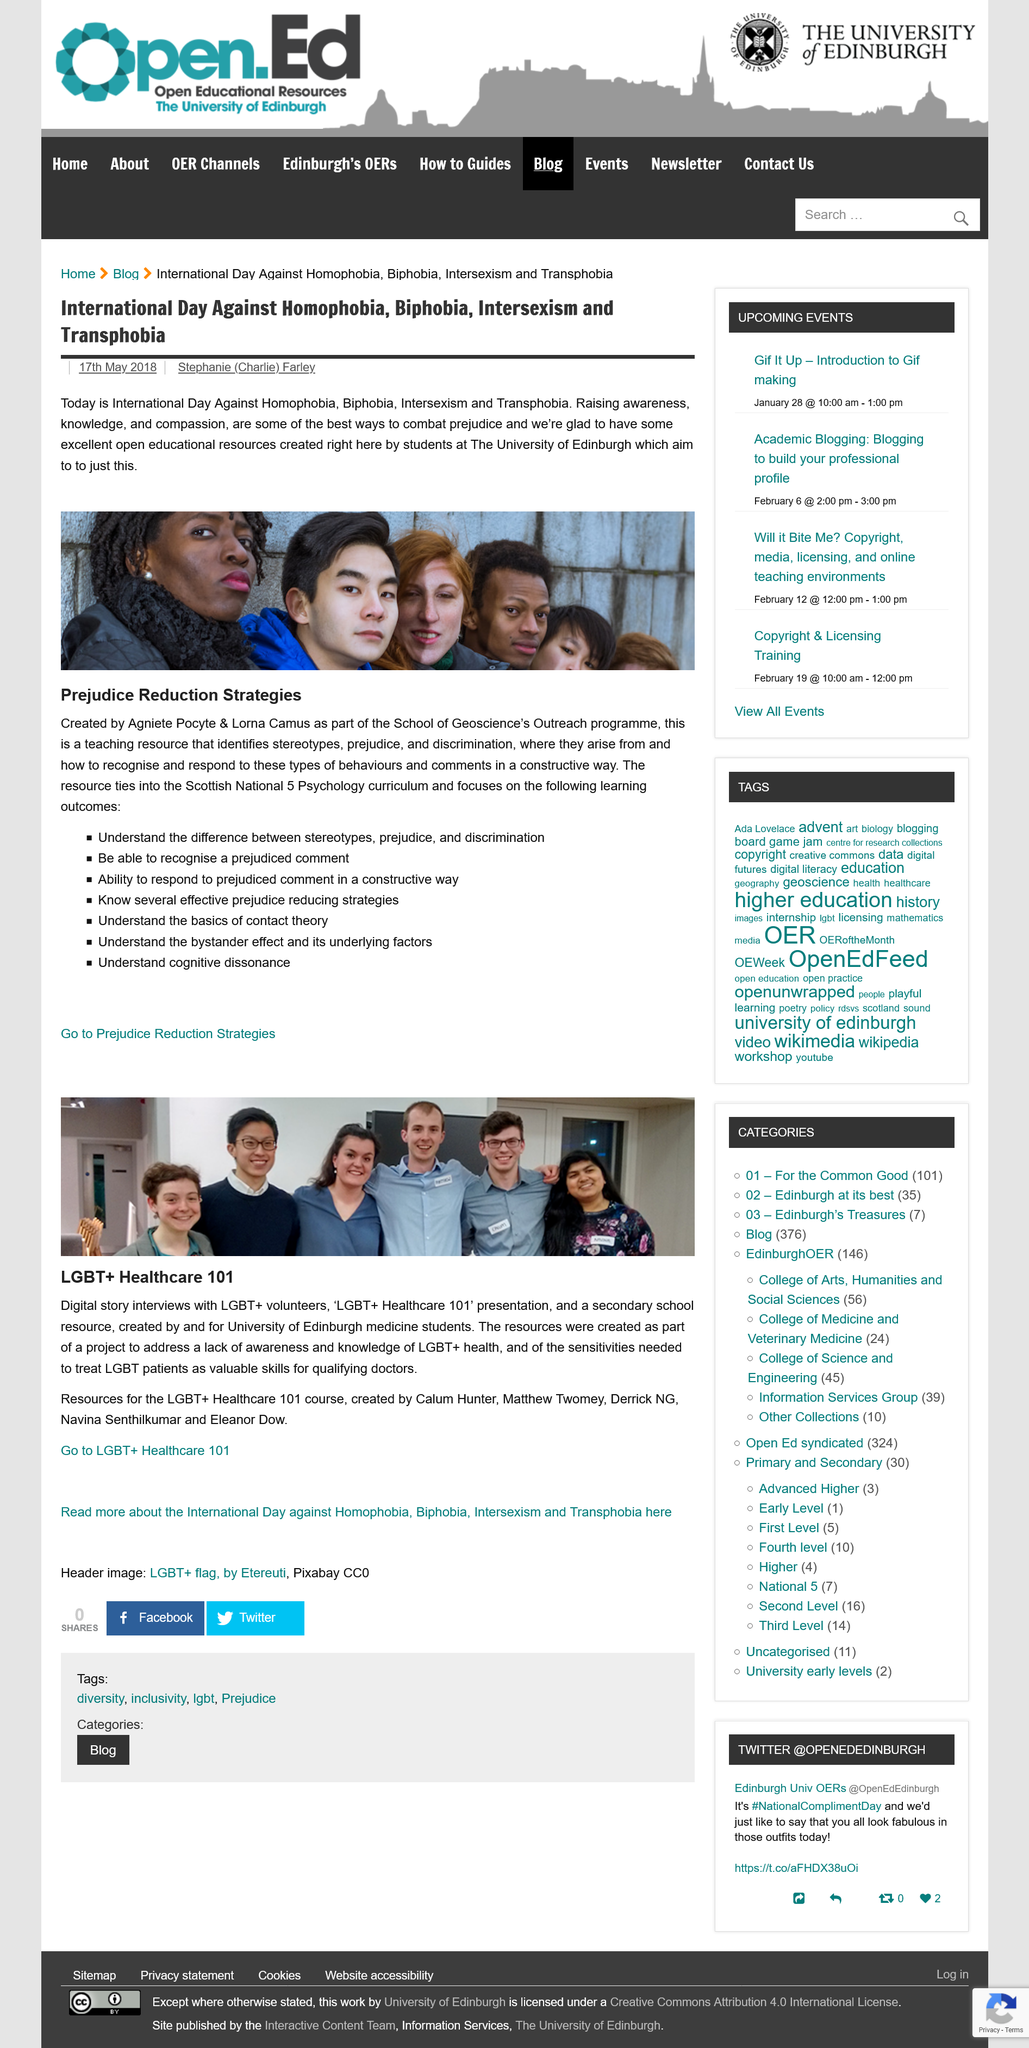Indicate a few pertinent items in this graphic. The 'LGBT+ Healthcare 101' presentation was presented by University of Edinburgh medicine students. This article discusses International Day against Homophobia, Biphobia, Intersexism, and Transphobia. The resources for this course were created by Calum Hunter, Matthew Twomey, Derrick MG, Navina Senthilkumar, and Eleanor Dow. The Prejudice Reduction Strategies were created by Agniete Pocyte and Lorna Camus. The primary purpose of these resources is to address the lack of awareness surrounding LGBT+ health and the sensitivities required to effectively treat LGBT patients. 